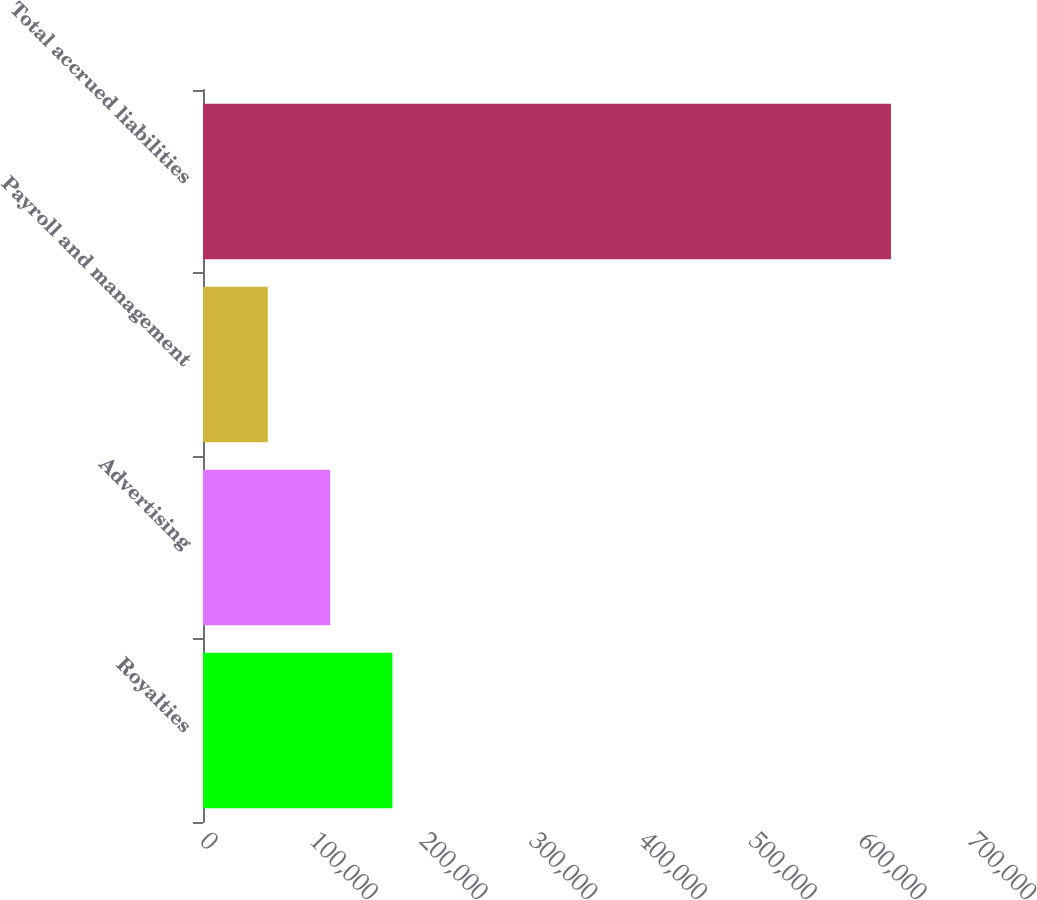<chart> <loc_0><loc_0><loc_500><loc_500><bar_chart><fcel>Royalties<fcel>Advertising<fcel>Payroll and management<fcel>Total accrued liabilities<nl><fcel>172666<fcel>115868<fcel>59070<fcel>627050<nl></chart> 